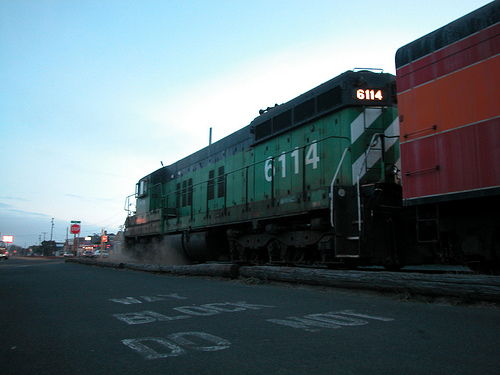What is the color of the train? The train in the image is green in color. 